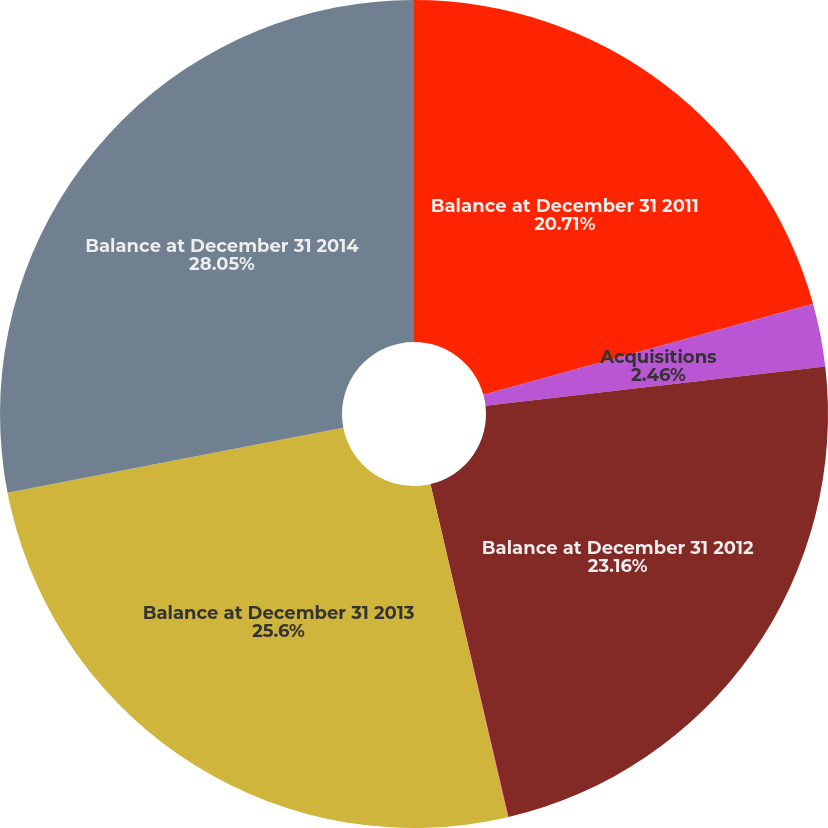Convert chart. <chart><loc_0><loc_0><loc_500><loc_500><pie_chart><fcel>Balance at December 31 2011<fcel>Acquisitions<fcel>Balance at December 31 2012<fcel>Foreign currency translation<fcel>Balance at December 31 2013<fcel>Balance at December 31 2014<nl><fcel>20.71%<fcel>2.46%<fcel>23.16%<fcel>0.02%<fcel>25.6%<fcel>28.04%<nl></chart> 